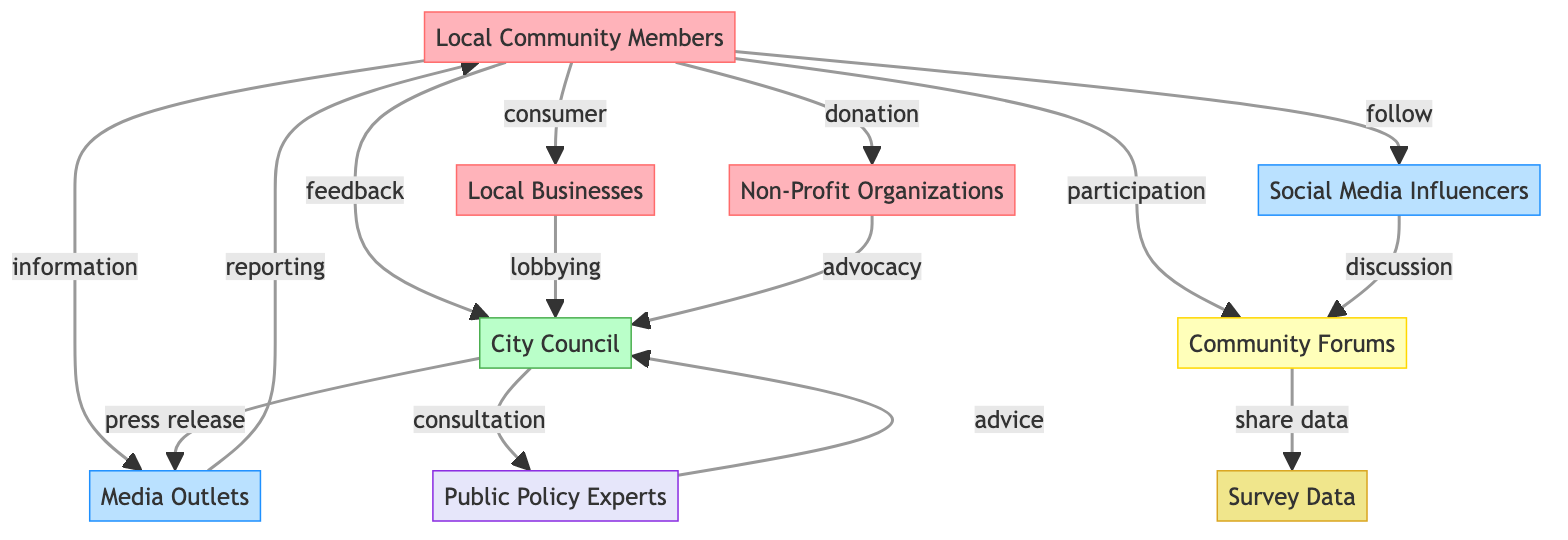What's the total number of nodes represented in the diagram? The diagram lists nine unique nodes, including local community members, city council, local businesses, non-profit organizations, media outlets, social media influencers, community forums, public policy experts, and survey data. Counting all of these gives a total of nine nodes.
Answer: 9 Which node follows the 'information' link from 'Local Community Members'? The link labeled 'information' connects 'Local Community Members' (node 1) to 'Media Outlets' (node 5). This means that the next node in this communication flow is 'Media Outlets'.
Answer: Media Outlets How many types of nodes are present in the diagram? The diagram categorizes nodes into five types: group (local community members, local businesses, non-profit organizations), government (city council), media (media outlets, social media influencers), platform (community forums), and expert (public policy experts). Therefore, there are five distinct types of nodes.
Answer: 5 What are the specific interactions between 'Local Businesses' and 'City Council'? The interaction between 'Local Businesses' (node 3) and 'City Council' (node 2) is labeled as 'lobbying', which is a type of communication. This indicates that local businesses directly communicate their interests and seek to influence local government actions.
Answer: lobbying Which node does 'Community Forums' share data with, and what kind of link is it? 'Community Forums' (node 7) shares data with 'Survey Data' (node 9) through a link labeled 'share data', which indicates an information exchange. This shows that community forums are involved in disseminating or discussing survey data.
Answer: Survey Data What is the nature of the connection between 'City Council' and 'Public Policy Experts'? The connection between 'City Council' (node 2) and 'Public Policy Experts' (node 8) is labeled as 'consultation', representing a type of communication. This suggests that the city council seeks input from experts regarding public policy decisions.
Answer: consultation How many communication links flow from 'Local Community Members'? There are four links that flow from 'Local Community Members' (node 1): to 'City Council' (feedback), 'Local Businesses' (consumer), 'Non-Profit Organizations' (donation), and 'Media Outlets' (information). Counting these gives a total of four communication links.
Answer: 4 What type of information is exchanged from 'Media Outlets' back to 'Local Community Members'? The type of information conveyed from 'Media Outlets' (node 5) to 'Local Community Members' (node 1) is 'reporting', indicating that media outlets provide news coverage or updates to the community members.
Answer: reporting Which node initiates the 'discussion' link? The 'discussion' link originates from 'Social Media Influencers' (node 6) to 'Community Forums' (node 7). This indicates that social media influencers engage in discussions within community forums.
Answer: Social Media Influencers 